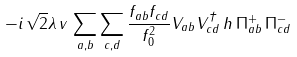Convert formula to latex. <formula><loc_0><loc_0><loc_500><loc_500>- i \, \sqrt { 2 } \lambda \, v \, \sum _ { a , b } \sum _ { c , d } \frac { f _ { a b } f _ { c d } } { f _ { 0 } ^ { 2 } } V _ { a b } V ^ { \dagger } _ { c d } \, h \, { \Pi } ^ { + } _ { a b } \, { \Pi } ^ { - } _ { c d }</formula> 